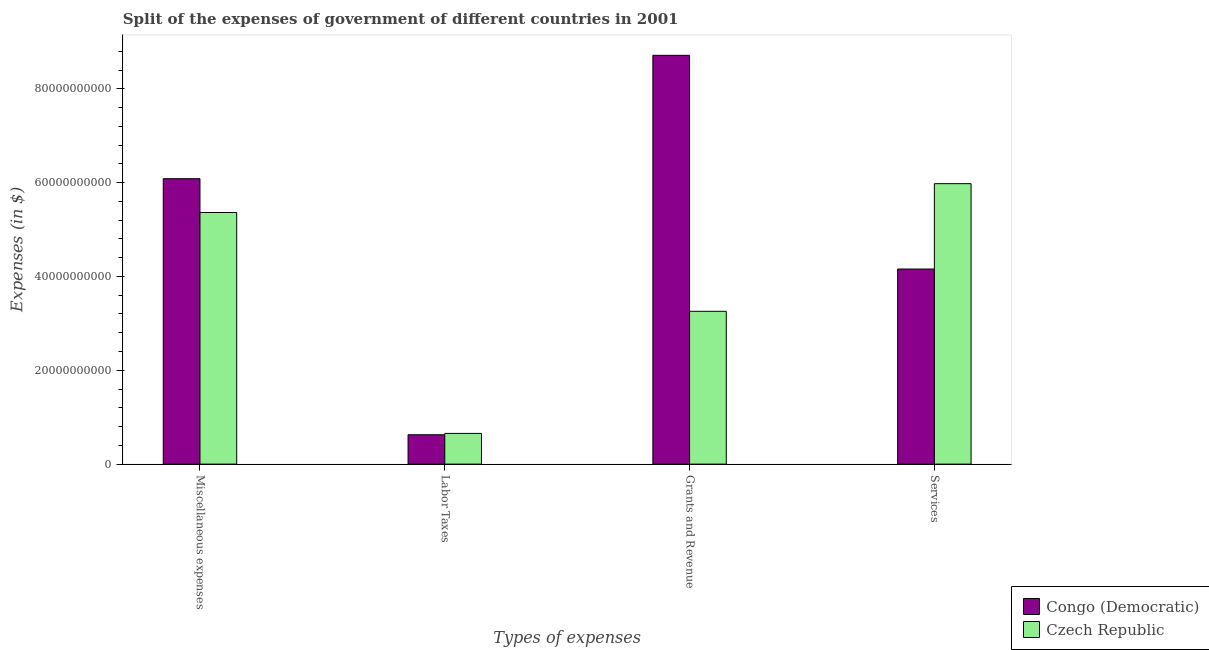How many different coloured bars are there?
Your response must be concise. 2. Are the number of bars per tick equal to the number of legend labels?
Provide a succinct answer. Yes. How many bars are there on the 2nd tick from the left?
Provide a succinct answer. 2. How many bars are there on the 3rd tick from the right?
Your answer should be very brief. 2. What is the label of the 2nd group of bars from the left?
Your answer should be compact. Labor Taxes. What is the amount spent on labor taxes in Congo (Democratic)?
Provide a short and direct response. 6.26e+09. Across all countries, what is the maximum amount spent on miscellaneous expenses?
Your answer should be compact. 6.08e+1. Across all countries, what is the minimum amount spent on miscellaneous expenses?
Your answer should be very brief. 5.36e+1. In which country was the amount spent on grants and revenue maximum?
Ensure brevity in your answer.  Congo (Democratic). In which country was the amount spent on services minimum?
Give a very brief answer. Congo (Democratic). What is the total amount spent on grants and revenue in the graph?
Offer a very short reply. 1.20e+11. What is the difference between the amount spent on miscellaneous expenses in Congo (Democratic) and that in Czech Republic?
Your answer should be compact. 7.20e+09. What is the difference between the amount spent on miscellaneous expenses in Congo (Democratic) and the amount spent on labor taxes in Czech Republic?
Your answer should be very brief. 5.43e+1. What is the average amount spent on miscellaneous expenses per country?
Your answer should be compact. 5.72e+1. What is the difference between the amount spent on labor taxes and amount spent on services in Congo (Democratic)?
Give a very brief answer. -3.53e+1. In how many countries, is the amount spent on labor taxes greater than 56000000000 $?
Ensure brevity in your answer.  0. What is the ratio of the amount spent on services in Czech Republic to that in Congo (Democratic)?
Provide a succinct answer. 1.44. Is the amount spent on labor taxes in Congo (Democratic) less than that in Czech Republic?
Provide a short and direct response. Yes. Is the difference between the amount spent on services in Czech Republic and Congo (Democratic) greater than the difference between the amount spent on grants and revenue in Czech Republic and Congo (Democratic)?
Offer a very short reply. Yes. What is the difference between the highest and the second highest amount spent on services?
Keep it short and to the point. 1.82e+1. What is the difference between the highest and the lowest amount spent on grants and revenue?
Offer a very short reply. 5.46e+1. What does the 1st bar from the left in Grants and Revenue represents?
Provide a short and direct response. Congo (Democratic). What does the 2nd bar from the right in Grants and Revenue represents?
Make the answer very short. Congo (Democratic). Is it the case that in every country, the sum of the amount spent on miscellaneous expenses and amount spent on labor taxes is greater than the amount spent on grants and revenue?
Offer a very short reply. No. How many countries are there in the graph?
Provide a succinct answer. 2. Are the values on the major ticks of Y-axis written in scientific E-notation?
Give a very brief answer. No. Does the graph contain any zero values?
Your response must be concise. No. Where does the legend appear in the graph?
Ensure brevity in your answer.  Bottom right. How many legend labels are there?
Give a very brief answer. 2. What is the title of the graph?
Offer a terse response. Split of the expenses of government of different countries in 2001. Does "Philippines" appear as one of the legend labels in the graph?
Provide a succinct answer. No. What is the label or title of the X-axis?
Provide a succinct answer. Types of expenses. What is the label or title of the Y-axis?
Your answer should be compact. Expenses (in $). What is the Expenses (in $) of Congo (Democratic) in Miscellaneous expenses?
Give a very brief answer. 6.08e+1. What is the Expenses (in $) of Czech Republic in Miscellaneous expenses?
Your response must be concise. 5.36e+1. What is the Expenses (in $) of Congo (Democratic) in Labor Taxes?
Offer a very short reply. 6.26e+09. What is the Expenses (in $) in Czech Republic in Labor Taxes?
Offer a terse response. 6.55e+09. What is the Expenses (in $) of Congo (Democratic) in Grants and Revenue?
Your answer should be very brief. 8.71e+1. What is the Expenses (in $) of Czech Republic in Grants and Revenue?
Provide a succinct answer. 3.26e+1. What is the Expenses (in $) in Congo (Democratic) in Services?
Provide a succinct answer. 4.16e+1. What is the Expenses (in $) of Czech Republic in Services?
Keep it short and to the point. 5.98e+1. Across all Types of expenses, what is the maximum Expenses (in $) in Congo (Democratic)?
Your answer should be compact. 8.71e+1. Across all Types of expenses, what is the maximum Expenses (in $) in Czech Republic?
Provide a succinct answer. 5.98e+1. Across all Types of expenses, what is the minimum Expenses (in $) in Congo (Democratic)?
Provide a short and direct response. 6.26e+09. Across all Types of expenses, what is the minimum Expenses (in $) in Czech Republic?
Make the answer very short. 6.55e+09. What is the total Expenses (in $) in Congo (Democratic) in the graph?
Your answer should be very brief. 1.96e+11. What is the total Expenses (in $) in Czech Republic in the graph?
Provide a short and direct response. 1.53e+11. What is the difference between the Expenses (in $) in Congo (Democratic) in Miscellaneous expenses and that in Labor Taxes?
Provide a succinct answer. 5.46e+1. What is the difference between the Expenses (in $) in Czech Republic in Miscellaneous expenses and that in Labor Taxes?
Provide a short and direct response. 4.71e+1. What is the difference between the Expenses (in $) of Congo (Democratic) in Miscellaneous expenses and that in Grants and Revenue?
Give a very brief answer. -2.63e+1. What is the difference between the Expenses (in $) of Czech Republic in Miscellaneous expenses and that in Grants and Revenue?
Your answer should be compact. 2.11e+1. What is the difference between the Expenses (in $) in Congo (Democratic) in Miscellaneous expenses and that in Services?
Make the answer very short. 1.93e+1. What is the difference between the Expenses (in $) of Czech Republic in Miscellaneous expenses and that in Services?
Provide a succinct answer. -6.15e+09. What is the difference between the Expenses (in $) in Congo (Democratic) in Labor Taxes and that in Grants and Revenue?
Provide a short and direct response. -8.09e+1. What is the difference between the Expenses (in $) in Czech Republic in Labor Taxes and that in Grants and Revenue?
Offer a very short reply. -2.60e+1. What is the difference between the Expenses (in $) of Congo (Democratic) in Labor Taxes and that in Services?
Give a very brief answer. -3.53e+1. What is the difference between the Expenses (in $) of Czech Republic in Labor Taxes and that in Services?
Give a very brief answer. -5.32e+1. What is the difference between the Expenses (in $) of Congo (Democratic) in Grants and Revenue and that in Services?
Ensure brevity in your answer.  4.56e+1. What is the difference between the Expenses (in $) of Czech Republic in Grants and Revenue and that in Services?
Your response must be concise. -2.72e+1. What is the difference between the Expenses (in $) of Congo (Democratic) in Miscellaneous expenses and the Expenses (in $) of Czech Republic in Labor Taxes?
Offer a terse response. 5.43e+1. What is the difference between the Expenses (in $) of Congo (Democratic) in Miscellaneous expenses and the Expenses (in $) of Czech Republic in Grants and Revenue?
Offer a terse response. 2.83e+1. What is the difference between the Expenses (in $) of Congo (Democratic) in Miscellaneous expenses and the Expenses (in $) of Czech Republic in Services?
Ensure brevity in your answer.  1.06e+09. What is the difference between the Expenses (in $) of Congo (Democratic) in Labor Taxes and the Expenses (in $) of Czech Republic in Grants and Revenue?
Offer a terse response. -2.63e+1. What is the difference between the Expenses (in $) of Congo (Democratic) in Labor Taxes and the Expenses (in $) of Czech Republic in Services?
Your answer should be very brief. -5.35e+1. What is the difference between the Expenses (in $) in Congo (Democratic) in Grants and Revenue and the Expenses (in $) in Czech Republic in Services?
Keep it short and to the point. 2.74e+1. What is the average Expenses (in $) in Congo (Democratic) per Types of expenses?
Ensure brevity in your answer.  4.90e+1. What is the average Expenses (in $) in Czech Republic per Types of expenses?
Offer a terse response. 3.81e+1. What is the difference between the Expenses (in $) in Congo (Democratic) and Expenses (in $) in Czech Republic in Miscellaneous expenses?
Offer a very short reply. 7.20e+09. What is the difference between the Expenses (in $) in Congo (Democratic) and Expenses (in $) in Czech Republic in Labor Taxes?
Keep it short and to the point. -2.90e+08. What is the difference between the Expenses (in $) of Congo (Democratic) and Expenses (in $) of Czech Republic in Grants and Revenue?
Offer a very short reply. 5.46e+1. What is the difference between the Expenses (in $) of Congo (Democratic) and Expenses (in $) of Czech Republic in Services?
Ensure brevity in your answer.  -1.82e+1. What is the ratio of the Expenses (in $) in Congo (Democratic) in Miscellaneous expenses to that in Labor Taxes?
Your response must be concise. 9.72. What is the ratio of the Expenses (in $) of Czech Republic in Miscellaneous expenses to that in Labor Taxes?
Your answer should be very brief. 8.19. What is the ratio of the Expenses (in $) in Congo (Democratic) in Miscellaneous expenses to that in Grants and Revenue?
Your response must be concise. 0.7. What is the ratio of the Expenses (in $) in Czech Republic in Miscellaneous expenses to that in Grants and Revenue?
Provide a succinct answer. 1.65. What is the ratio of the Expenses (in $) in Congo (Democratic) in Miscellaneous expenses to that in Services?
Offer a terse response. 1.46. What is the ratio of the Expenses (in $) in Czech Republic in Miscellaneous expenses to that in Services?
Provide a short and direct response. 0.9. What is the ratio of the Expenses (in $) of Congo (Democratic) in Labor Taxes to that in Grants and Revenue?
Give a very brief answer. 0.07. What is the ratio of the Expenses (in $) of Czech Republic in Labor Taxes to that in Grants and Revenue?
Make the answer very short. 0.2. What is the ratio of the Expenses (in $) of Congo (Democratic) in Labor Taxes to that in Services?
Ensure brevity in your answer.  0.15. What is the ratio of the Expenses (in $) in Czech Republic in Labor Taxes to that in Services?
Provide a succinct answer. 0.11. What is the ratio of the Expenses (in $) of Congo (Democratic) in Grants and Revenue to that in Services?
Keep it short and to the point. 2.1. What is the ratio of the Expenses (in $) of Czech Republic in Grants and Revenue to that in Services?
Your answer should be very brief. 0.54. What is the difference between the highest and the second highest Expenses (in $) of Congo (Democratic)?
Ensure brevity in your answer.  2.63e+1. What is the difference between the highest and the second highest Expenses (in $) in Czech Republic?
Give a very brief answer. 6.15e+09. What is the difference between the highest and the lowest Expenses (in $) of Congo (Democratic)?
Your answer should be compact. 8.09e+1. What is the difference between the highest and the lowest Expenses (in $) in Czech Republic?
Your answer should be compact. 5.32e+1. 